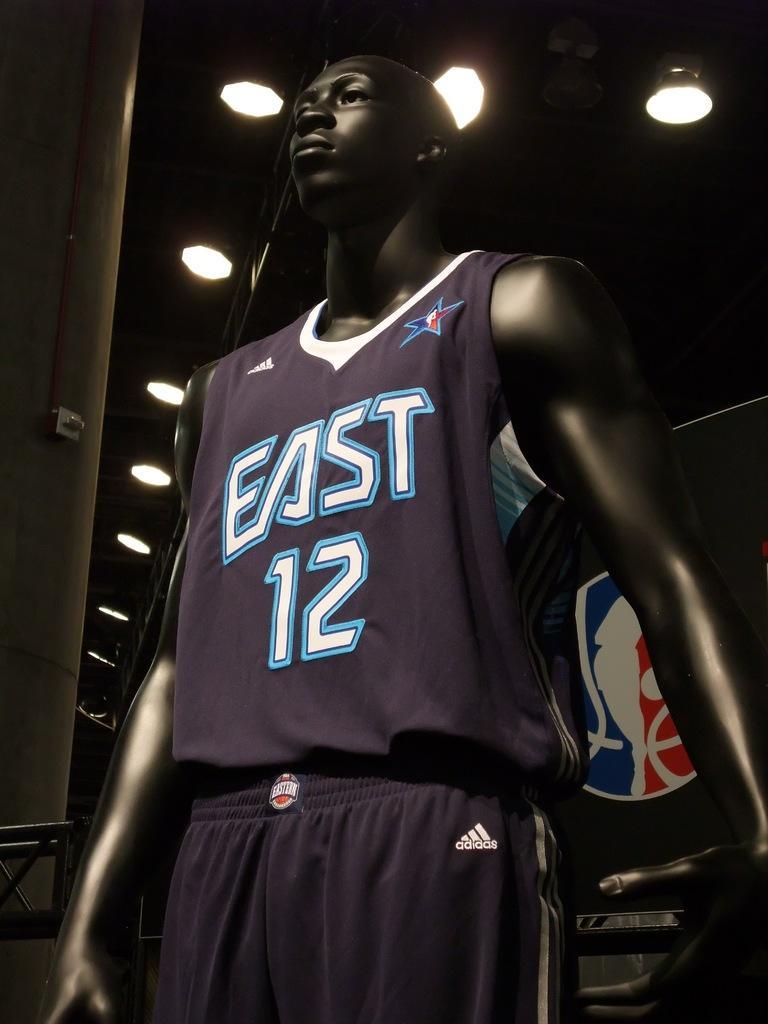Can you describe this image briefly? In this image we can see a dress on a mannequin. On the backside we can see some ceiling lights to a roof. 